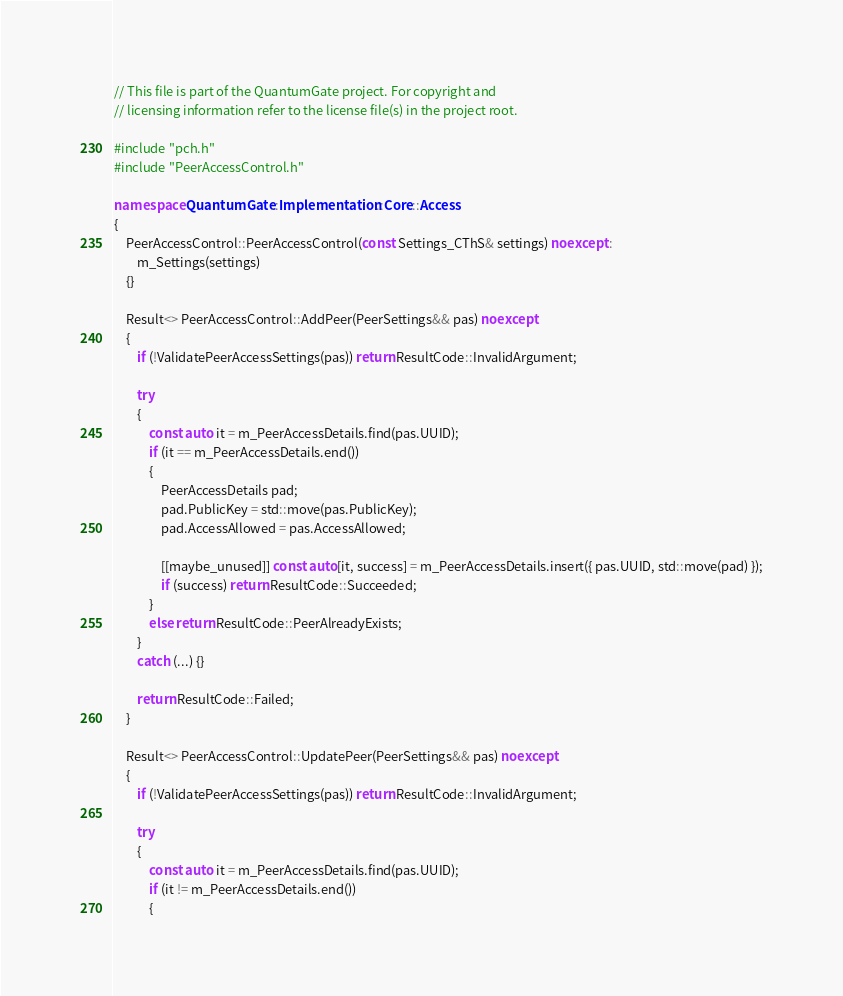<code> <loc_0><loc_0><loc_500><loc_500><_C++_>// This file is part of the QuantumGate project. For copyright and
// licensing information refer to the license file(s) in the project root.

#include "pch.h"
#include "PeerAccessControl.h"

namespace QuantumGate::Implementation::Core::Access
{
	PeerAccessControl::PeerAccessControl(const Settings_CThS& settings) noexcept :
		m_Settings(settings)
	{}

	Result<> PeerAccessControl::AddPeer(PeerSettings&& pas) noexcept
	{
		if (!ValidatePeerAccessSettings(pas)) return ResultCode::InvalidArgument;

		try
		{
			const auto it = m_PeerAccessDetails.find(pas.UUID);
			if (it == m_PeerAccessDetails.end())
			{
				PeerAccessDetails pad;
				pad.PublicKey = std::move(pas.PublicKey);
				pad.AccessAllowed = pas.AccessAllowed;

				[[maybe_unused]] const auto[it, success] = m_PeerAccessDetails.insert({ pas.UUID, std::move(pad) });
				if (success) return ResultCode::Succeeded;
			}
			else return ResultCode::PeerAlreadyExists;
		}
		catch (...) {}

		return ResultCode::Failed;
	}

	Result<> PeerAccessControl::UpdatePeer(PeerSettings&& pas) noexcept
	{
		if (!ValidatePeerAccessSettings(pas)) return ResultCode::InvalidArgument;

		try
		{
			const auto it = m_PeerAccessDetails.find(pas.UUID);
			if (it != m_PeerAccessDetails.end())
			{</code> 